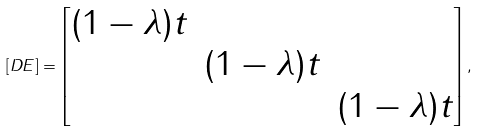<formula> <loc_0><loc_0><loc_500><loc_500>[ D E ] = \begin{bmatrix} ( 1 - \lambda ) t & & \\ & ( 1 - \lambda ) t & \\ & & ( 1 - \lambda ) t \\ \end{bmatrix} ,</formula> 